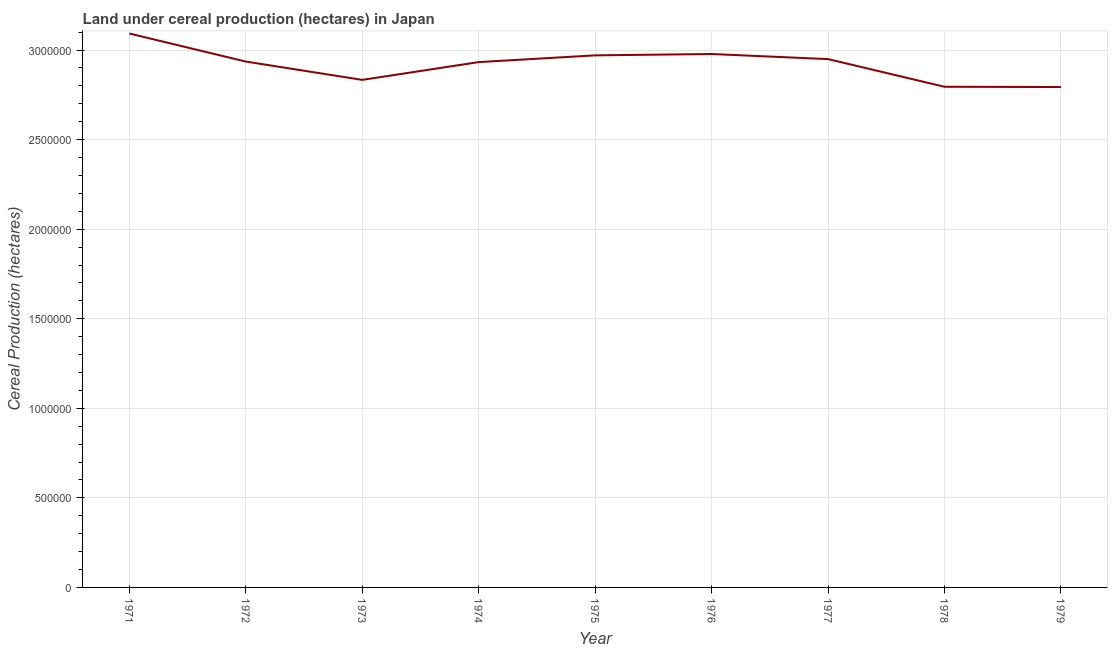What is the land under cereal production in 1972?
Ensure brevity in your answer.  2.94e+06. Across all years, what is the maximum land under cereal production?
Your answer should be very brief. 3.09e+06. Across all years, what is the minimum land under cereal production?
Offer a very short reply. 2.79e+06. In which year was the land under cereal production minimum?
Provide a short and direct response. 1979. What is the sum of the land under cereal production?
Provide a short and direct response. 2.63e+07. What is the difference between the land under cereal production in 1972 and 1974?
Make the answer very short. 3060. What is the average land under cereal production per year?
Provide a succinct answer. 2.92e+06. What is the median land under cereal production?
Your answer should be compact. 2.94e+06. In how many years, is the land under cereal production greater than 2300000 hectares?
Provide a succinct answer. 9. Do a majority of the years between 1973 and 1978 (inclusive) have land under cereal production greater than 200000 hectares?
Offer a terse response. Yes. What is the ratio of the land under cereal production in 1971 to that in 1974?
Keep it short and to the point. 1.05. What is the difference between the highest and the second highest land under cereal production?
Offer a terse response. 1.15e+05. Is the sum of the land under cereal production in 1972 and 1976 greater than the maximum land under cereal production across all years?
Your response must be concise. Yes. What is the difference between the highest and the lowest land under cereal production?
Your answer should be very brief. 2.99e+05. Does the land under cereal production monotonically increase over the years?
Keep it short and to the point. No. How many lines are there?
Provide a succinct answer. 1. How many years are there in the graph?
Ensure brevity in your answer.  9. What is the difference between two consecutive major ticks on the Y-axis?
Make the answer very short. 5.00e+05. Are the values on the major ticks of Y-axis written in scientific E-notation?
Your response must be concise. No. What is the title of the graph?
Keep it short and to the point. Land under cereal production (hectares) in Japan. What is the label or title of the X-axis?
Give a very brief answer. Year. What is the label or title of the Y-axis?
Give a very brief answer. Cereal Production (hectares). What is the Cereal Production (hectares) in 1971?
Give a very brief answer. 3.09e+06. What is the Cereal Production (hectares) in 1972?
Ensure brevity in your answer.  2.94e+06. What is the Cereal Production (hectares) in 1973?
Make the answer very short. 2.83e+06. What is the Cereal Production (hectares) in 1974?
Your response must be concise. 2.93e+06. What is the Cereal Production (hectares) of 1975?
Your answer should be compact. 2.97e+06. What is the Cereal Production (hectares) in 1976?
Provide a short and direct response. 2.98e+06. What is the Cereal Production (hectares) of 1977?
Keep it short and to the point. 2.95e+06. What is the Cereal Production (hectares) of 1978?
Your answer should be compact. 2.80e+06. What is the Cereal Production (hectares) of 1979?
Offer a terse response. 2.79e+06. What is the difference between the Cereal Production (hectares) in 1971 and 1972?
Your answer should be very brief. 1.57e+05. What is the difference between the Cereal Production (hectares) in 1971 and 1973?
Provide a succinct answer. 2.59e+05. What is the difference between the Cereal Production (hectares) in 1971 and 1974?
Your answer should be very brief. 1.60e+05. What is the difference between the Cereal Production (hectares) in 1971 and 1975?
Your answer should be compact. 1.22e+05. What is the difference between the Cereal Production (hectares) in 1971 and 1976?
Give a very brief answer. 1.15e+05. What is the difference between the Cereal Production (hectares) in 1971 and 1977?
Your response must be concise. 1.43e+05. What is the difference between the Cereal Production (hectares) in 1971 and 1978?
Your response must be concise. 2.97e+05. What is the difference between the Cereal Production (hectares) in 1971 and 1979?
Your answer should be very brief. 2.99e+05. What is the difference between the Cereal Production (hectares) in 1972 and 1973?
Offer a terse response. 1.02e+05. What is the difference between the Cereal Production (hectares) in 1972 and 1974?
Provide a succinct answer. 3060. What is the difference between the Cereal Production (hectares) in 1972 and 1975?
Make the answer very short. -3.46e+04. What is the difference between the Cereal Production (hectares) in 1972 and 1976?
Provide a short and direct response. -4.20e+04. What is the difference between the Cereal Production (hectares) in 1972 and 1977?
Give a very brief answer. -1.37e+04. What is the difference between the Cereal Production (hectares) in 1972 and 1978?
Give a very brief answer. 1.41e+05. What is the difference between the Cereal Production (hectares) in 1972 and 1979?
Your answer should be very brief. 1.42e+05. What is the difference between the Cereal Production (hectares) in 1973 and 1974?
Give a very brief answer. -9.92e+04. What is the difference between the Cereal Production (hectares) in 1973 and 1975?
Offer a terse response. -1.37e+05. What is the difference between the Cereal Production (hectares) in 1973 and 1976?
Keep it short and to the point. -1.44e+05. What is the difference between the Cereal Production (hectares) in 1973 and 1977?
Offer a terse response. -1.16e+05. What is the difference between the Cereal Production (hectares) in 1973 and 1978?
Keep it short and to the point. 3.84e+04. What is the difference between the Cereal Production (hectares) in 1973 and 1979?
Ensure brevity in your answer.  4.01e+04. What is the difference between the Cereal Production (hectares) in 1974 and 1975?
Make the answer very short. -3.77e+04. What is the difference between the Cereal Production (hectares) in 1974 and 1976?
Ensure brevity in your answer.  -4.51e+04. What is the difference between the Cereal Production (hectares) in 1974 and 1977?
Your answer should be very brief. -1.68e+04. What is the difference between the Cereal Production (hectares) in 1974 and 1978?
Provide a succinct answer. 1.38e+05. What is the difference between the Cereal Production (hectares) in 1974 and 1979?
Offer a terse response. 1.39e+05. What is the difference between the Cereal Production (hectares) in 1975 and 1976?
Make the answer very short. -7440. What is the difference between the Cereal Production (hectares) in 1975 and 1977?
Keep it short and to the point. 2.09e+04. What is the difference between the Cereal Production (hectares) in 1975 and 1978?
Keep it short and to the point. 1.75e+05. What is the difference between the Cereal Production (hectares) in 1975 and 1979?
Provide a succinct answer. 1.77e+05. What is the difference between the Cereal Production (hectares) in 1976 and 1977?
Offer a terse response. 2.83e+04. What is the difference between the Cereal Production (hectares) in 1976 and 1978?
Offer a very short reply. 1.83e+05. What is the difference between the Cereal Production (hectares) in 1976 and 1979?
Offer a terse response. 1.84e+05. What is the difference between the Cereal Production (hectares) in 1977 and 1978?
Provide a short and direct response. 1.54e+05. What is the difference between the Cereal Production (hectares) in 1977 and 1979?
Your response must be concise. 1.56e+05. What is the difference between the Cereal Production (hectares) in 1978 and 1979?
Your answer should be compact. 1616. What is the ratio of the Cereal Production (hectares) in 1971 to that in 1972?
Your answer should be compact. 1.05. What is the ratio of the Cereal Production (hectares) in 1971 to that in 1973?
Make the answer very short. 1.09. What is the ratio of the Cereal Production (hectares) in 1971 to that in 1974?
Offer a terse response. 1.05. What is the ratio of the Cereal Production (hectares) in 1971 to that in 1975?
Offer a terse response. 1.04. What is the ratio of the Cereal Production (hectares) in 1971 to that in 1976?
Keep it short and to the point. 1.04. What is the ratio of the Cereal Production (hectares) in 1971 to that in 1977?
Provide a short and direct response. 1.05. What is the ratio of the Cereal Production (hectares) in 1971 to that in 1978?
Your response must be concise. 1.11. What is the ratio of the Cereal Production (hectares) in 1971 to that in 1979?
Make the answer very short. 1.11. What is the ratio of the Cereal Production (hectares) in 1972 to that in 1973?
Provide a succinct answer. 1.04. What is the ratio of the Cereal Production (hectares) in 1972 to that in 1974?
Make the answer very short. 1. What is the ratio of the Cereal Production (hectares) in 1972 to that in 1975?
Your answer should be compact. 0.99. What is the ratio of the Cereal Production (hectares) in 1972 to that in 1978?
Provide a short and direct response. 1.05. What is the ratio of the Cereal Production (hectares) in 1972 to that in 1979?
Your answer should be compact. 1.05. What is the ratio of the Cereal Production (hectares) in 1973 to that in 1975?
Provide a succinct answer. 0.95. What is the ratio of the Cereal Production (hectares) in 1973 to that in 1976?
Keep it short and to the point. 0.95. What is the ratio of the Cereal Production (hectares) in 1973 to that in 1979?
Your answer should be compact. 1.01. What is the ratio of the Cereal Production (hectares) in 1974 to that in 1977?
Make the answer very short. 0.99. What is the ratio of the Cereal Production (hectares) in 1974 to that in 1978?
Make the answer very short. 1.05. What is the ratio of the Cereal Production (hectares) in 1975 to that in 1976?
Your answer should be very brief. 1. What is the ratio of the Cereal Production (hectares) in 1975 to that in 1977?
Keep it short and to the point. 1.01. What is the ratio of the Cereal Production (hectares) in 1975 to that in 1978?
Offer a terse response. 1.06. What is the ratio of the Cereal Production (hectares) in 1975 to that in 1979?
Make the answer very short. 1.06. What is the ratio of the Cereal Production (hectares) in 1976 to that in 1977?
Make the answer very short. 1.01. What is the ratio of the Cereal Production (hectares) in 1976 to that in 1978?
Your response must be concise. 1.06. What is the ratio of the Cereal Production (hectares) in 1976 to that in 1979?
Your response must be concise. 1.07. What is the ratio of the Cereal Production (hectares) in 1977 to that in 1978?
Offer a terse response. 1.05. What is the ratio of the Cereal Production (hectares) in 1977 to that in 1979?
Ensure brevity in your answer.  1.06. What is the ratio of the Cereal Production (hectares) in 1978 to that in 1979?
Your answer should be very brief. 1. 